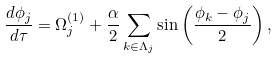Convert formula to latex. <formula><loc_0><loc_0><loc_500><loc_500>\frac { d \phi _ { j } } { d \tau } = \Omega _ { j } ^ { ( 1 ) } + \frac { \alpha } { 2 } \sum _ { k \in \Lambda _ { j } } \sin \left ( \frac { \phi _ { k } - \phi _ { j } } { 2 } \right ) ,</formula> 